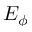Convert formula to latex. <formula><loc_0><loc_0><loc_500><loc_500>E _ { \phi }</formula> 